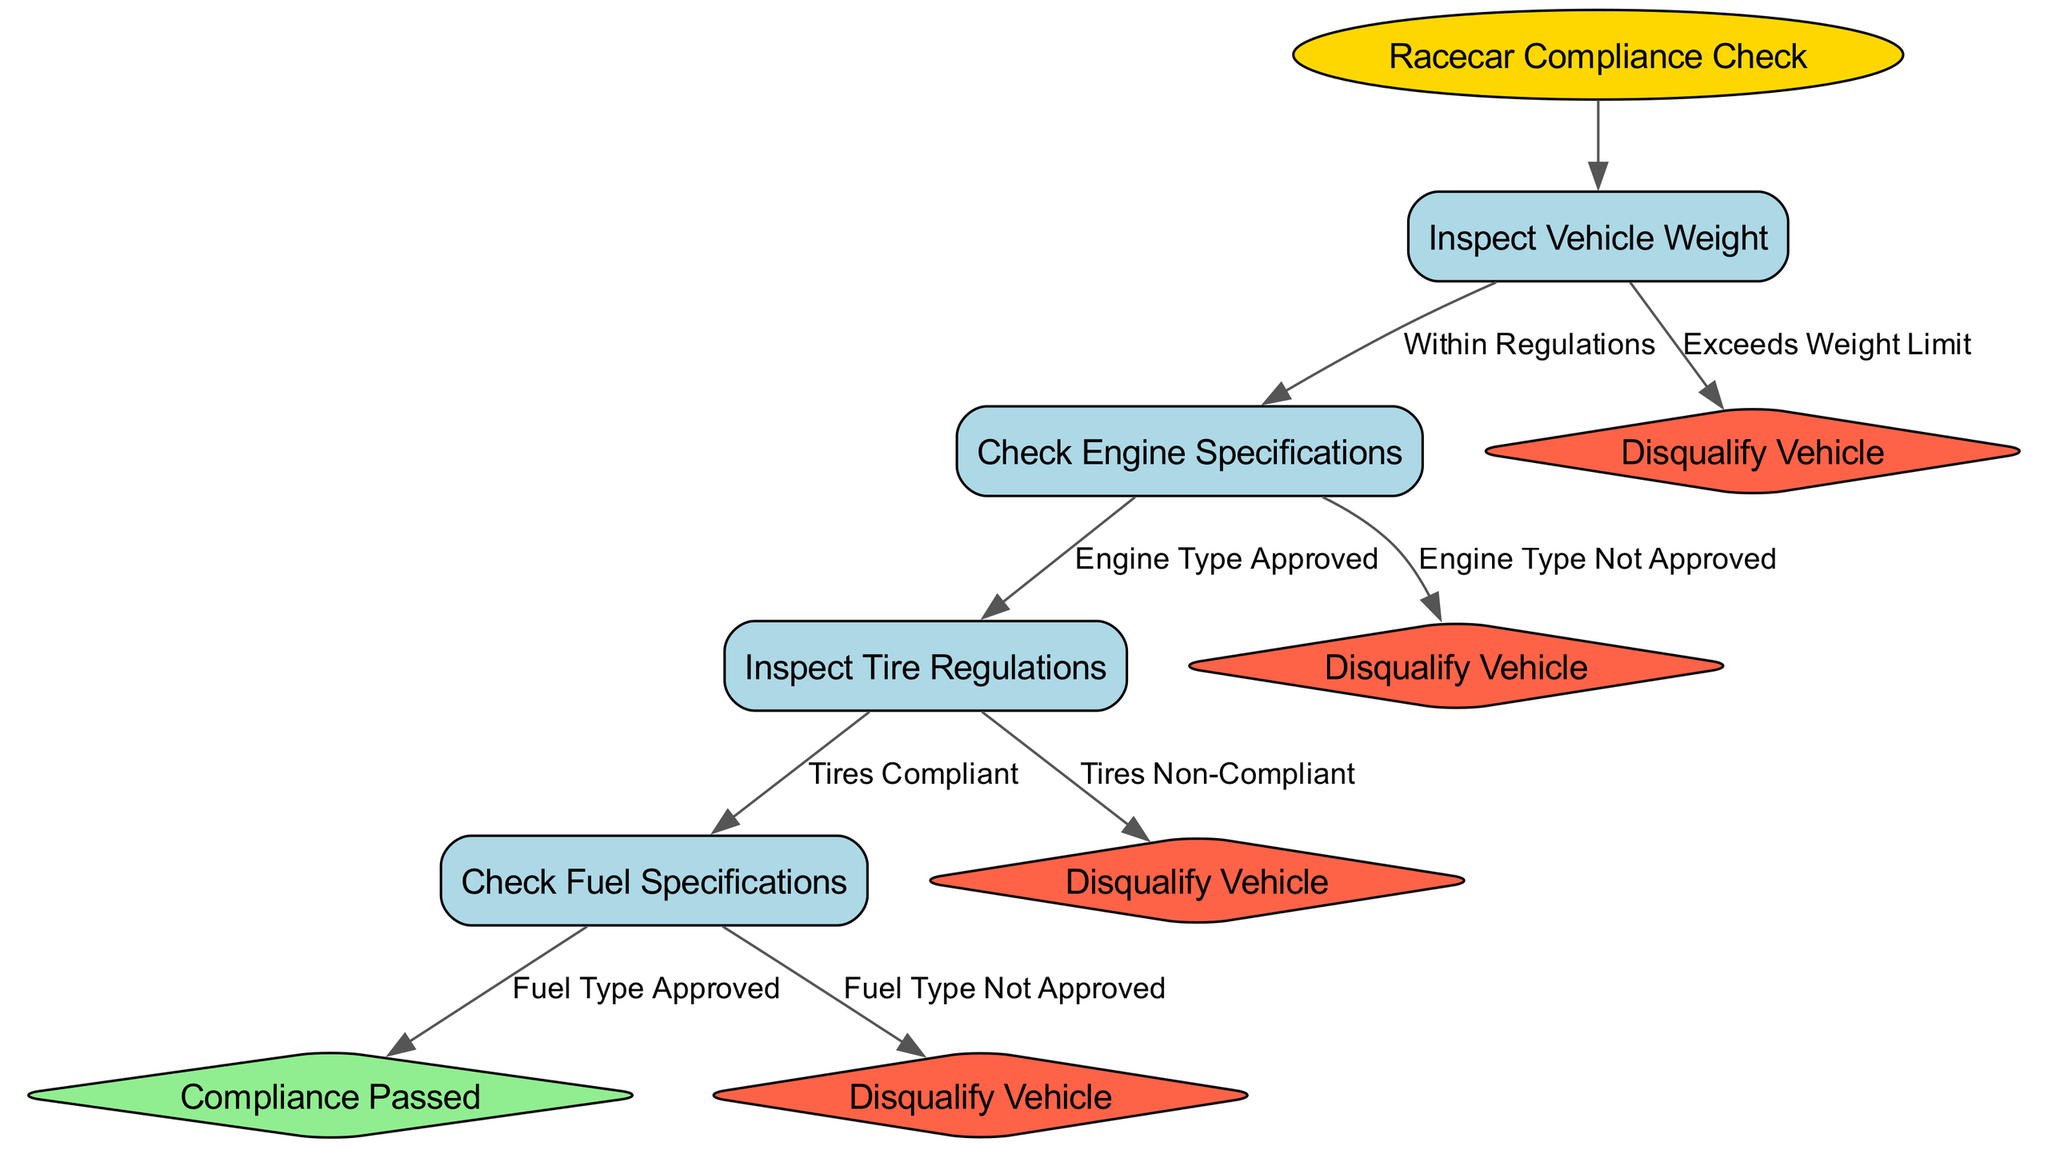What is the first step in the compliance check? The diagram indicates that the first step in the compliance check is to "Inspect Vehicle Weight." This is the root node from which all checks proceed.
Answer: Inspect Vehicle Weight What happens if the vehicle exceeds the weight limit? According to the diagram, if the vehicle exceeds the weight limit, the next action is to "Disqualify Vehicle." This is indicated as a terminal node in the decision tree.
Answer: Disqualify Vehicle How many nodes are present in the decision tree? The decision tree consists of a total of four nodes related to compliance checks, each representing a different inspection step. Counting both the root and the options leads to a total of five nodes.
Answer: Five What is the last step if all checks are passed? If all checks are completed successfully, the final step noted in the diagram is "Compliance Passed." This indicates that the vehicle meets all technical specifications.
Answer: Compliance Passed What follows after inspecting tire regulations if the tires are compliant? The next step after "Inspect Tire Regulations," in case the tires are compliant, is to "Check Fuel Specifications," as shown in the flow of the decision tree.
Answer: Check Fuel Specifications If the engine type is not approved, what is the outcome? The diagram shows that if the "Engine Type Not Approved" is the conclusion from "Check Engine Specifications," the outcome is to "Disqualify Vehicle." This indicates a direct relationship between the engine inspection result and disqualification.
Answer: Disqualify Vehicle What is the consequence of using fuel type not approved? According to the decision tree, if the "Fuel Type Not Approved" is determined during the "Check Fuel Specifications," the vehicle will be "Disqualified." This shows that the fuel type is critical for compliance.
Answer: Disqualify Vehicle Name a node that leads directly to disqualification. The decision tree specifies two nodes that lead directly to disqualification: "Exceeds Weight Limit" and "Engine Type Not Approved." Both options result in the disqualification of the vehicle.
Answer: Exceeds Weight Limit, Engine Type Not Approved 